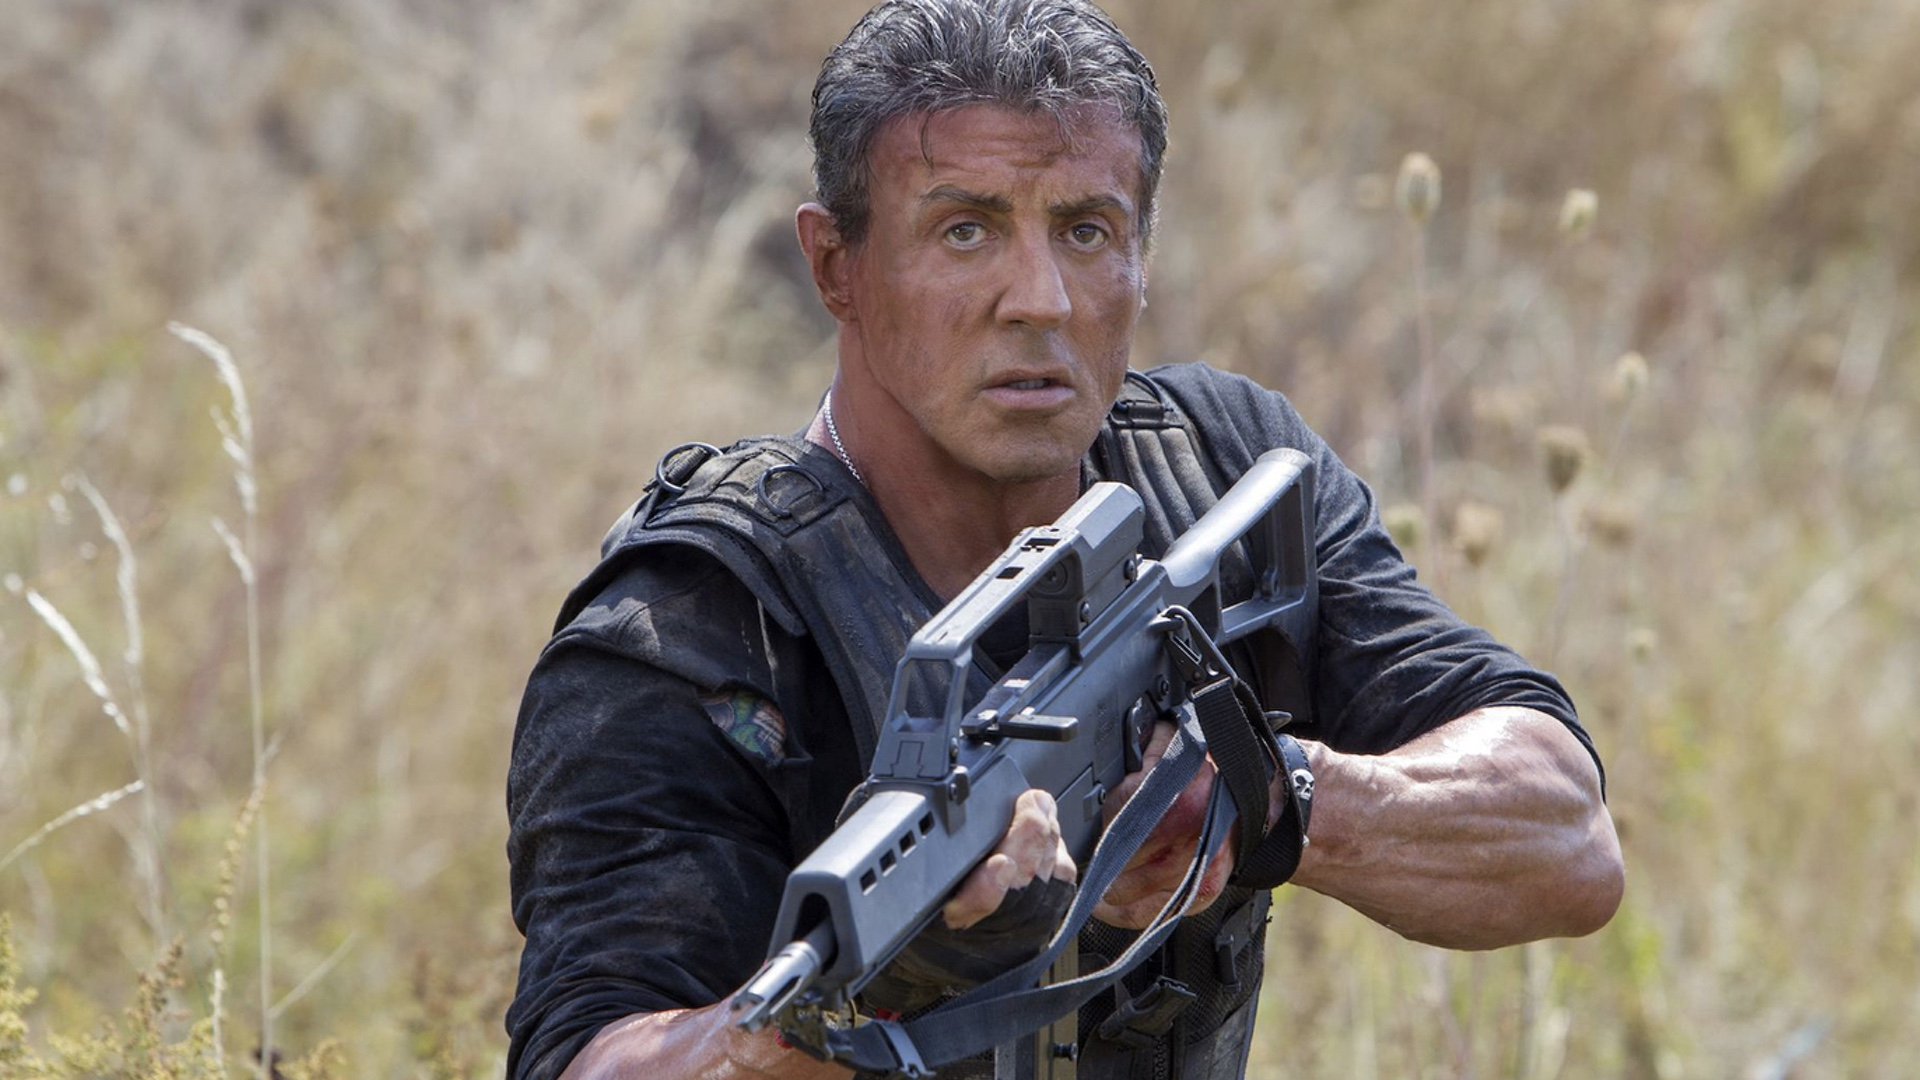How does the natural environment interact with the character's presence? The natural setting of tall grass and undisturbed flora forms a striking contrast to the character's combative readiness. This juxtaposition highlights a narrative tension between the serenity of the environment and the violence his presence suggests. Can you discuss the impact of lighting in this scene? The overcast lighting in the scene adds a muted, somber tone, enhancing the seriousness of the moment. It ensures no shadows overshadow his face, focusing attention on his emotional and physical state. 